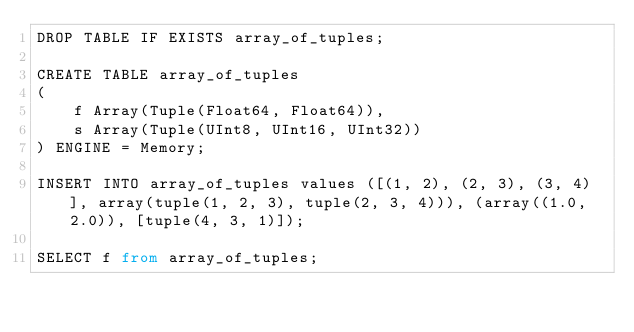<code> <loc_0><loc_0><loc_500><loc_500><_SQL_>DROP TABLE IF EXISTS array_of_tuples;

CREATE TABLE array_of_tuples 
(
    f Array(Tuple(Float64, Float64)), 
    s Array(Tuple(UInt8, UInt16, UInt32))
) ENGINE = Memory;

INSERT INTO array_of_tuples values ([(1, 2), (2, 3), (3, 4)], array(tuple(1, 2, 3), tuple(2, 3, 4))), (array((1.0, 2.0)), [tuple(4, 3, 1)]);

SELECT f from array_of_tuples;</code> 